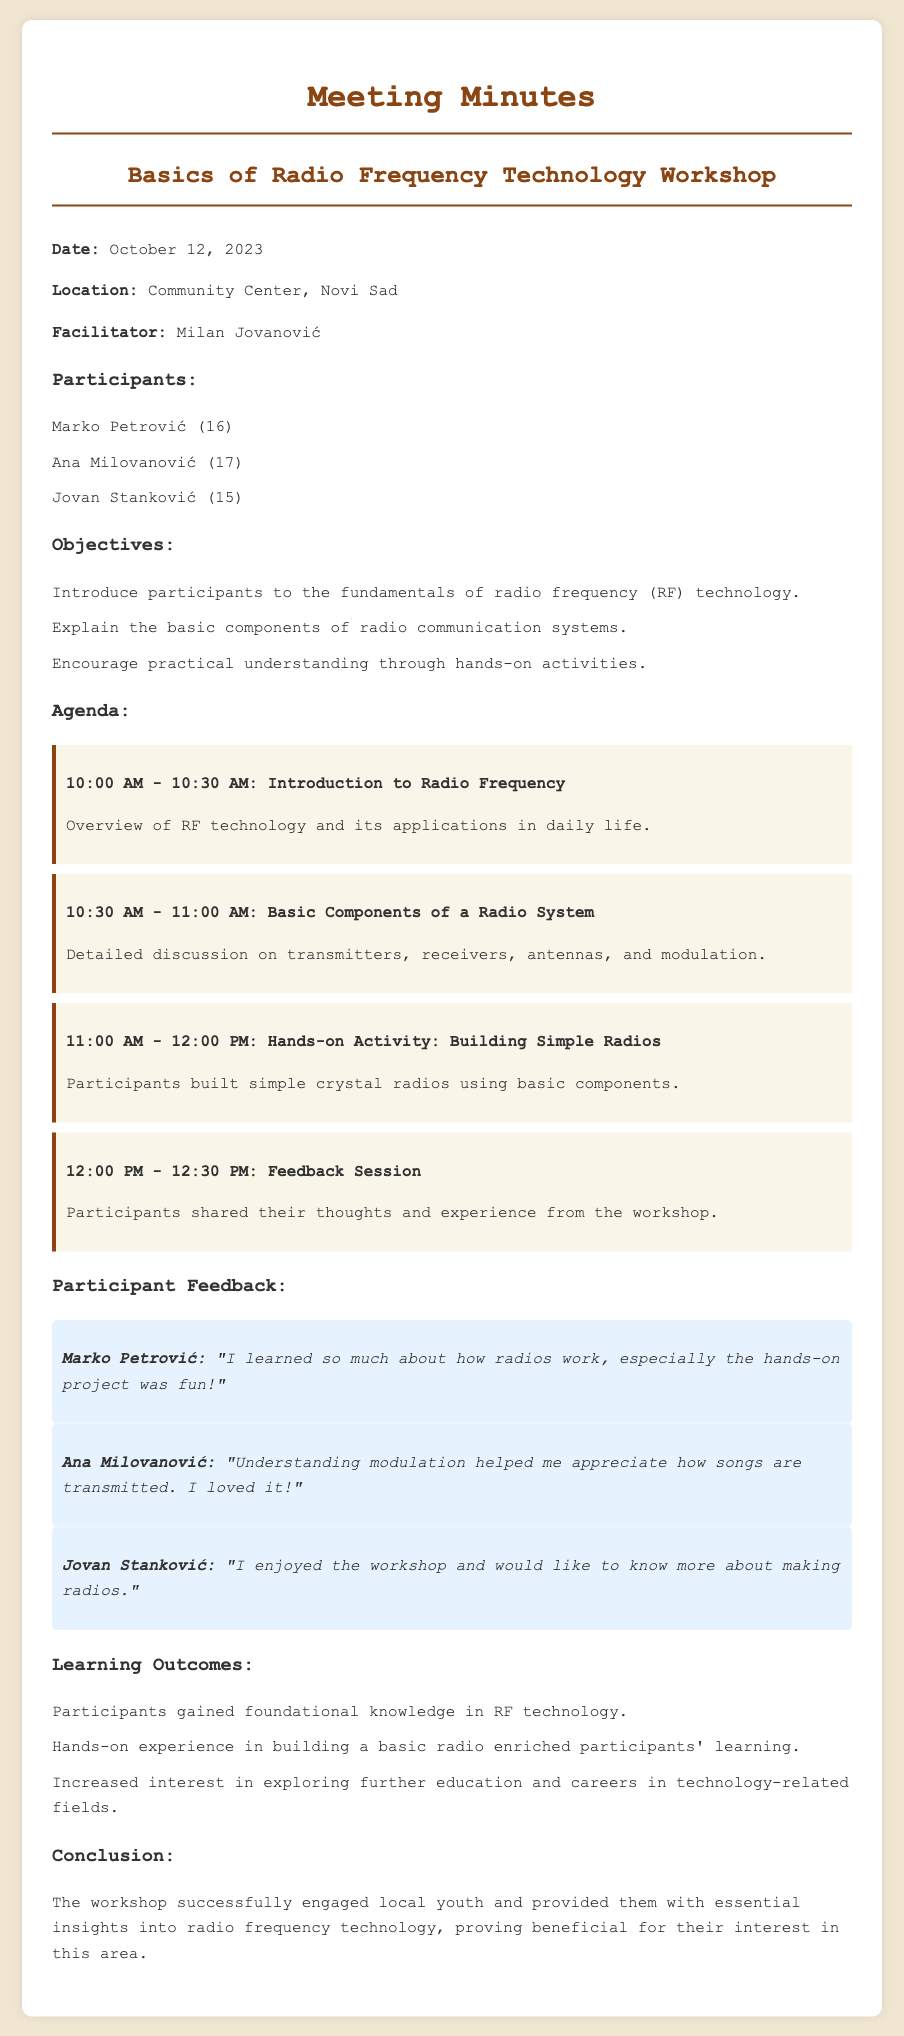What is the date of the workshop? The date of the workshop is mentioned in the document as October 12, 2023.
Answer: October 12, 2023 Who was the facilitator of the workshop? The name of the facilitator is listed in the document as Milan Jovanović.
Answer: Milan Jovanović How many participants attended the workshop? The document lists three participants, hence the total number is three.
Answer: 3 What was one of the hands-on activities? The hands-on activity described in the document involved building simple radios.
Answer: Building simple radios What was Marko Petrović's feedback? Marko Petrović's feedback highlights that he learned much about how radios work and enjoyed the hands-on project.
Answer: "I learned so much about how radios work, especially the hands-on project was fun!" What was one objective of the workshop? One of the objectives mentioned is to introduce participants to the fundamentals of radio frequency technology.
Answer: Introduce participants to the fundamentals of radio frequency technology What increased interest did the workshop aim to foster? A goal of the workshop was to increase interest in exploring further education and careers in technology-related fields.
Answer: Exploring further education and careers in technology-related fields What conclusion was drawn about the workshop's effectiveness? The document concludes that the workshop successfully engaged local youth and provided essential insights into radio frequency technology.
Answer: Successfully engaged local youth and provided essential insights into radio frequency technology 